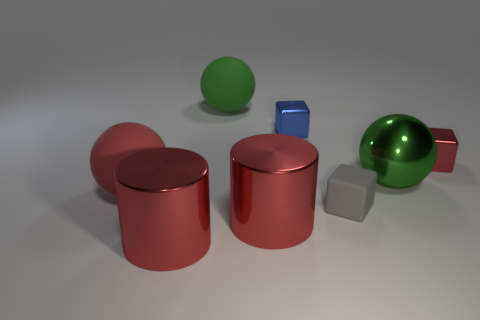There is a thing that is left of the blue metal thing and behind the red cube; what is its material?
Offer a terse response. Rubber. Do the blue metal thing and the green rubber object have the same shape?
Ensure brevity in your answer.  No. Are there any other things that are the same size as the green metallic thing?
Make the answer very short. Yes. There is a gray matte block; what number of blue objects are in front of it?
Offer a terse response. 0. There is a shiny cylinder that is to the right of the green matte ball; is it the same size as the tiny gray block?
Your response must be concise. No. There is a tiny rubber thing that is the same shape as the tiny blue metallic thing; what is its color?
Keep it short and to the point. Gray. Are there any other things that are the same shape as the tiny gray object?
Provide a short and direct response. Yes. There is a red shiny object to the right of the small gray rubber block; what is its shape?
Offer a very short reply. Cube. How many purple objects have the same shape as the blue object?
Offer a very short reply. 0. There is a metallic cube that is behind the red metal block; is it the same color as the large matte ball that is behind the red rubber thing?
Make the answer very short. No. 